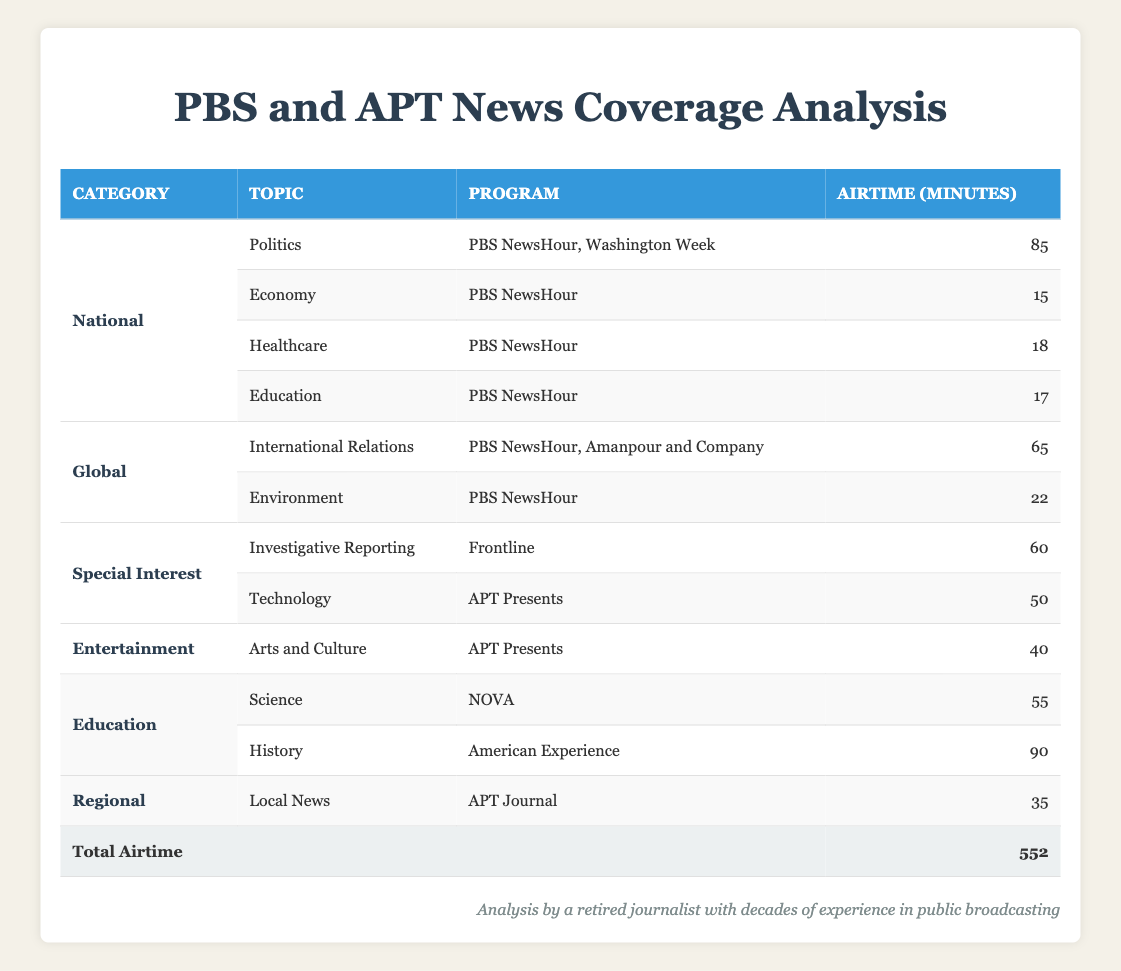What is the total airtime for news topics in the National category? The National category has four topics covered: Politics (85 minutes), Economy (15 minutes), Healthcare (18 minutes), and Education (17 minutes). Adding these together: 85 + 15 + 18 + 17 = 135 minutes.
Answer: 135 minutes Which program had the most airtime dedicated to a single topic? The program that had the most airtime dedicated to a single topic is American Experience, which covered History for 90 minutes.
Answer: American Experience How many topics were covered under the Global category? There are two topics under the Global category: International Relations and Environment. Therefore, the count of topics is 2.
Answer: 2 Was Politics the most covered topic across all programs? Yes, Politics was covered a total of 85 minutes across two programs (PBS NewsHour and Washington Week), which is the highest airtime for any single topic.
Answer: Yes What is the average airtime of programs in the Education category? The Education category includes two topics: Science (55 minutes) and History (90 minutes). To find the average, we sum the airtime (55 + 90 = 145 minutes) and divide by the number of topics (2): 145 / 2 = 72.5 minutes.
Answer: 72.5 minutes Which category had the least airtime in total? The Regional category has only one topic, Local News, which had 35 minutes of airtime. Other categories had more airtime dedicated; hence, Regional has the least total airtime.
Answer: Regional How much airtime did PBS NewsHour allocate for topics in the Global category? PBS NewsHour covered two topics in the Global category: International Relations (20 minutes) and Environment (22 minutes). Summing them gives: 20 + 22 = 42 minutes.
Answer: 42 minutes Is there any program that focuses solely on the Special Interest category? Yes, the program Frontline focuses solely on the topic Investigative Reporting in the Special Interest category, which had 60 minutes of airtime.
Answer: Yes 